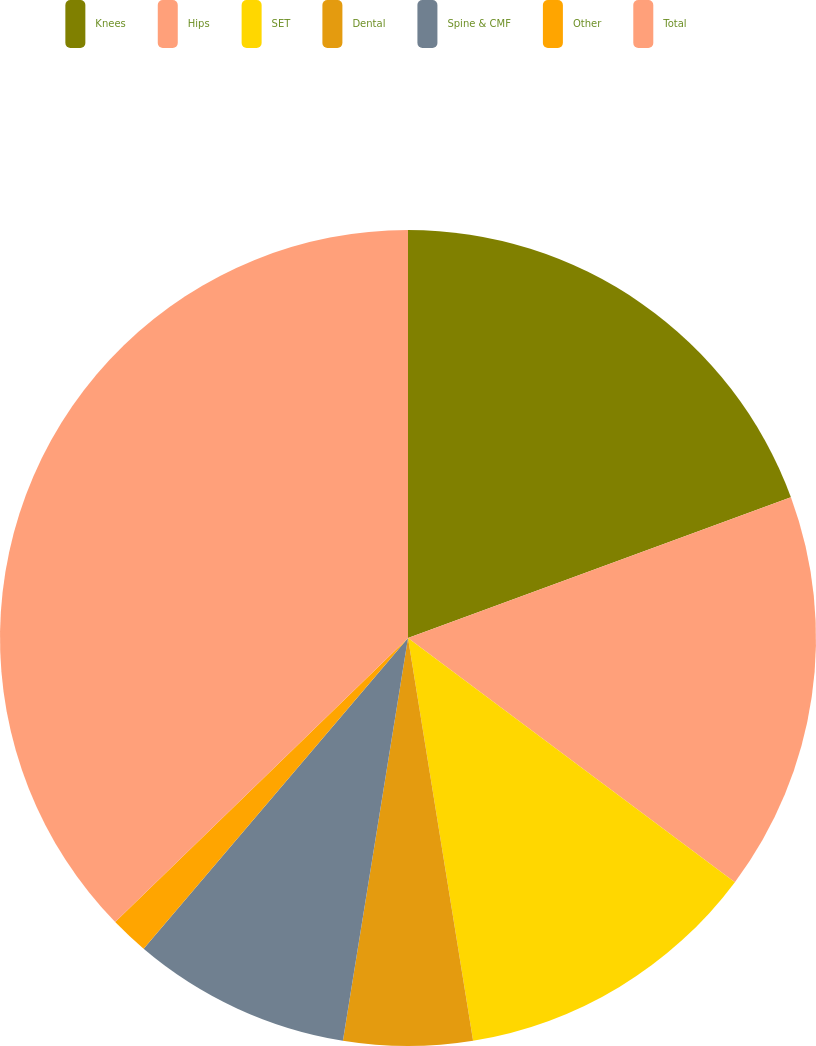<chart> <loc_0><loc_0><loc_500><loc_500><pie_chart><fcel>Knees<fcel>Hips<fcel>SET<fcel>Dental<fcel>Spine & CMF<fcel>Other<fcel>Total<nl><fcel>19.39%<fcel>15.82%<fcel>12.24%<fcel>5.1%<fcel>8.67%<fcel>1.52%<fcel>37.26%<nl></chart> 